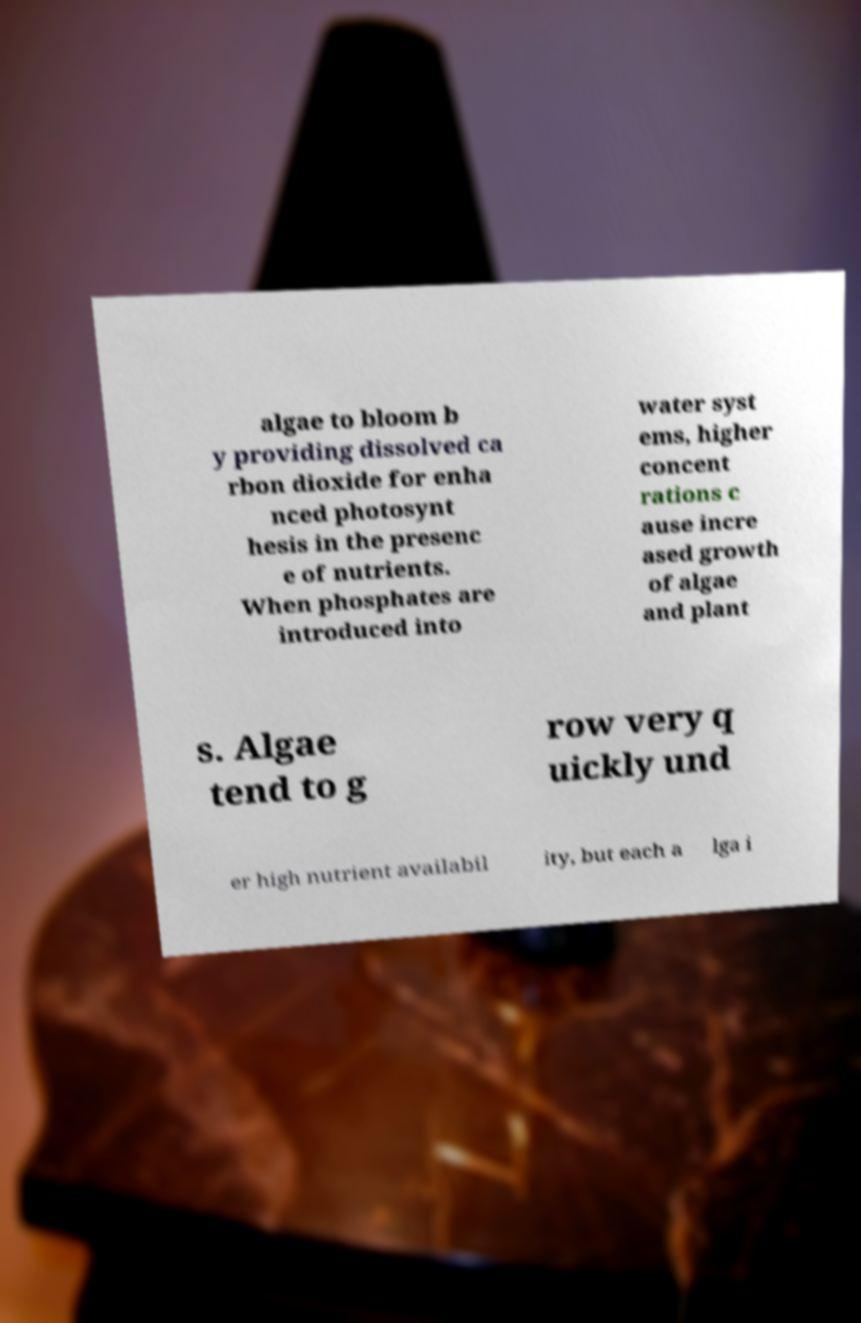For documentation purposes, I need the text within this image transcribed. Could you provide that? algae to bloom b y providing dissolved ca rbon dioxide for enha nced photosynt hesis in the presenc e of nutrients. When phosphates are introduced into water syst ems, higher concent rations c ause incre ased growth of algae and plant s. Algae tend to g row very q uickly und er high nutrient availabil ity, but each a lga i 